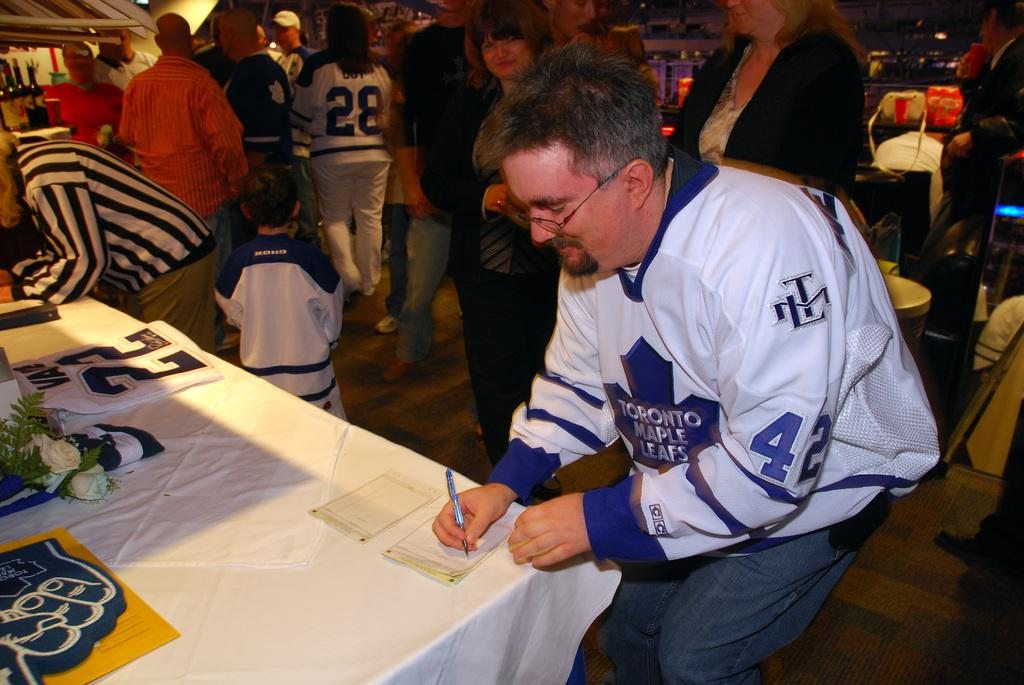Provide a one-sentence caption for the provided image. A man in a Toronto Maple Leafs jersey writing at a table. 